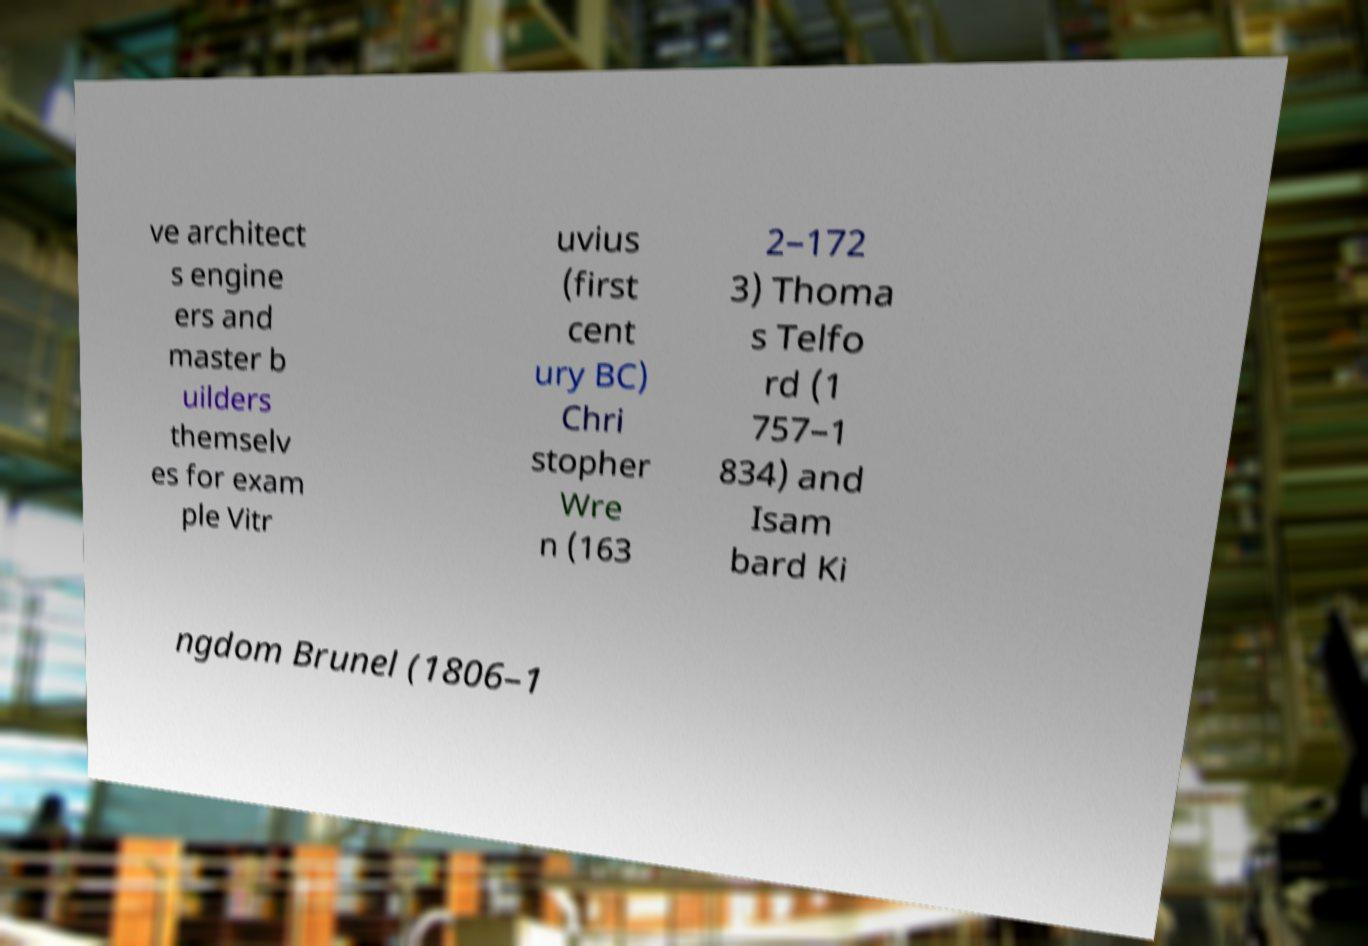Could you assist in decoding the text presented in this image and type it out clearly? ve architect s engine ers and master b uilders themselv es for exam ple Vitr uvius (first cent ury BC) Chri stopher Wre n (163 2–172 3) Thoma s Telfo rd (1 757–1 834) and Isam bard Ki ngdom Brunel (1806–1 